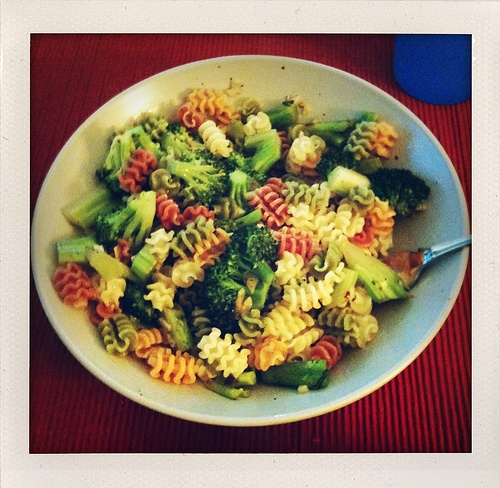Describe the objects in this image and their specific colors. I can see bowl in lightgray, black, tan, khaki, and olive tones, dining table in lightgray, maroon, black, brown, and navy tones, broccoli in lightgray, black, darkgreen, and green tones, cup in lightgray, navy, darkblue, black, and maroon tones, and broccoli in lightgray, black, darkgreen, olive, and khaki tones in this image. 